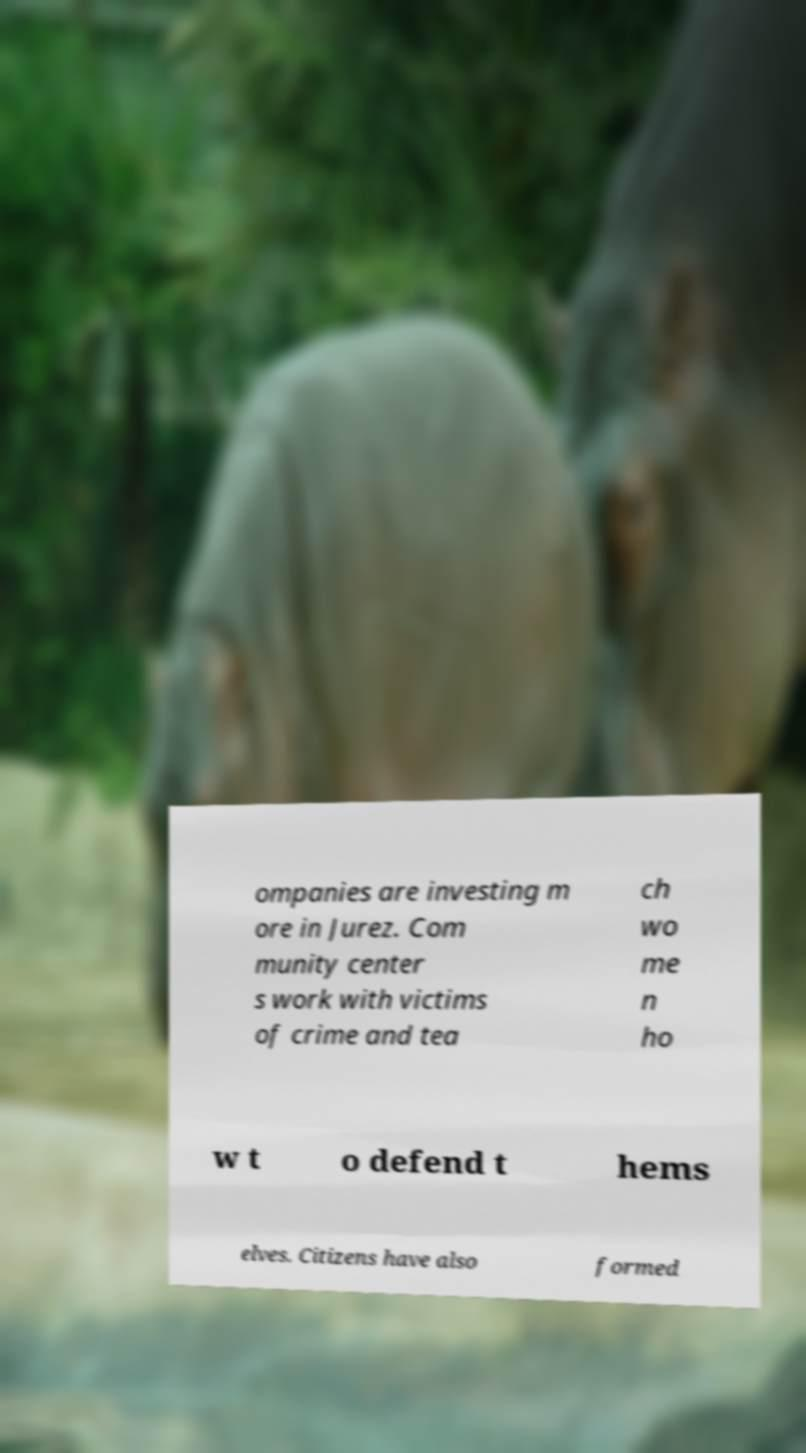What messages or text are displayed in this image? I need them in a readable, typed format. ompanies are investing m ore in Jurez. Com munity center s work with victims of crime and tea ch wo me n ho w t o defend t hems elves. Citizens have also formed 